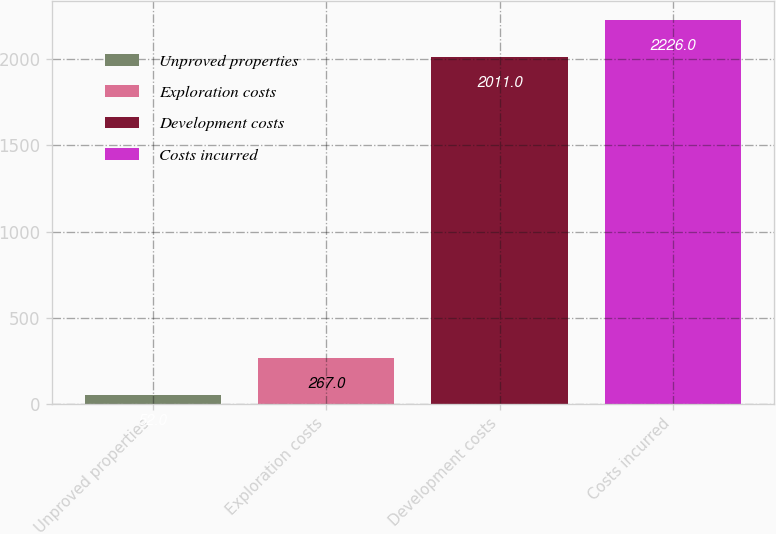Convert chart to OTSL. <chart><loc_0><loc_0><loc_500><loc_500><bar_chart><fcel>Unproved properties<fcel>Exploration costs<fcel>Development costs<fcel>Costs incurred<nl><fcel>52<fcel>267<fcel>2011<fcel>2226<nl></chart> 